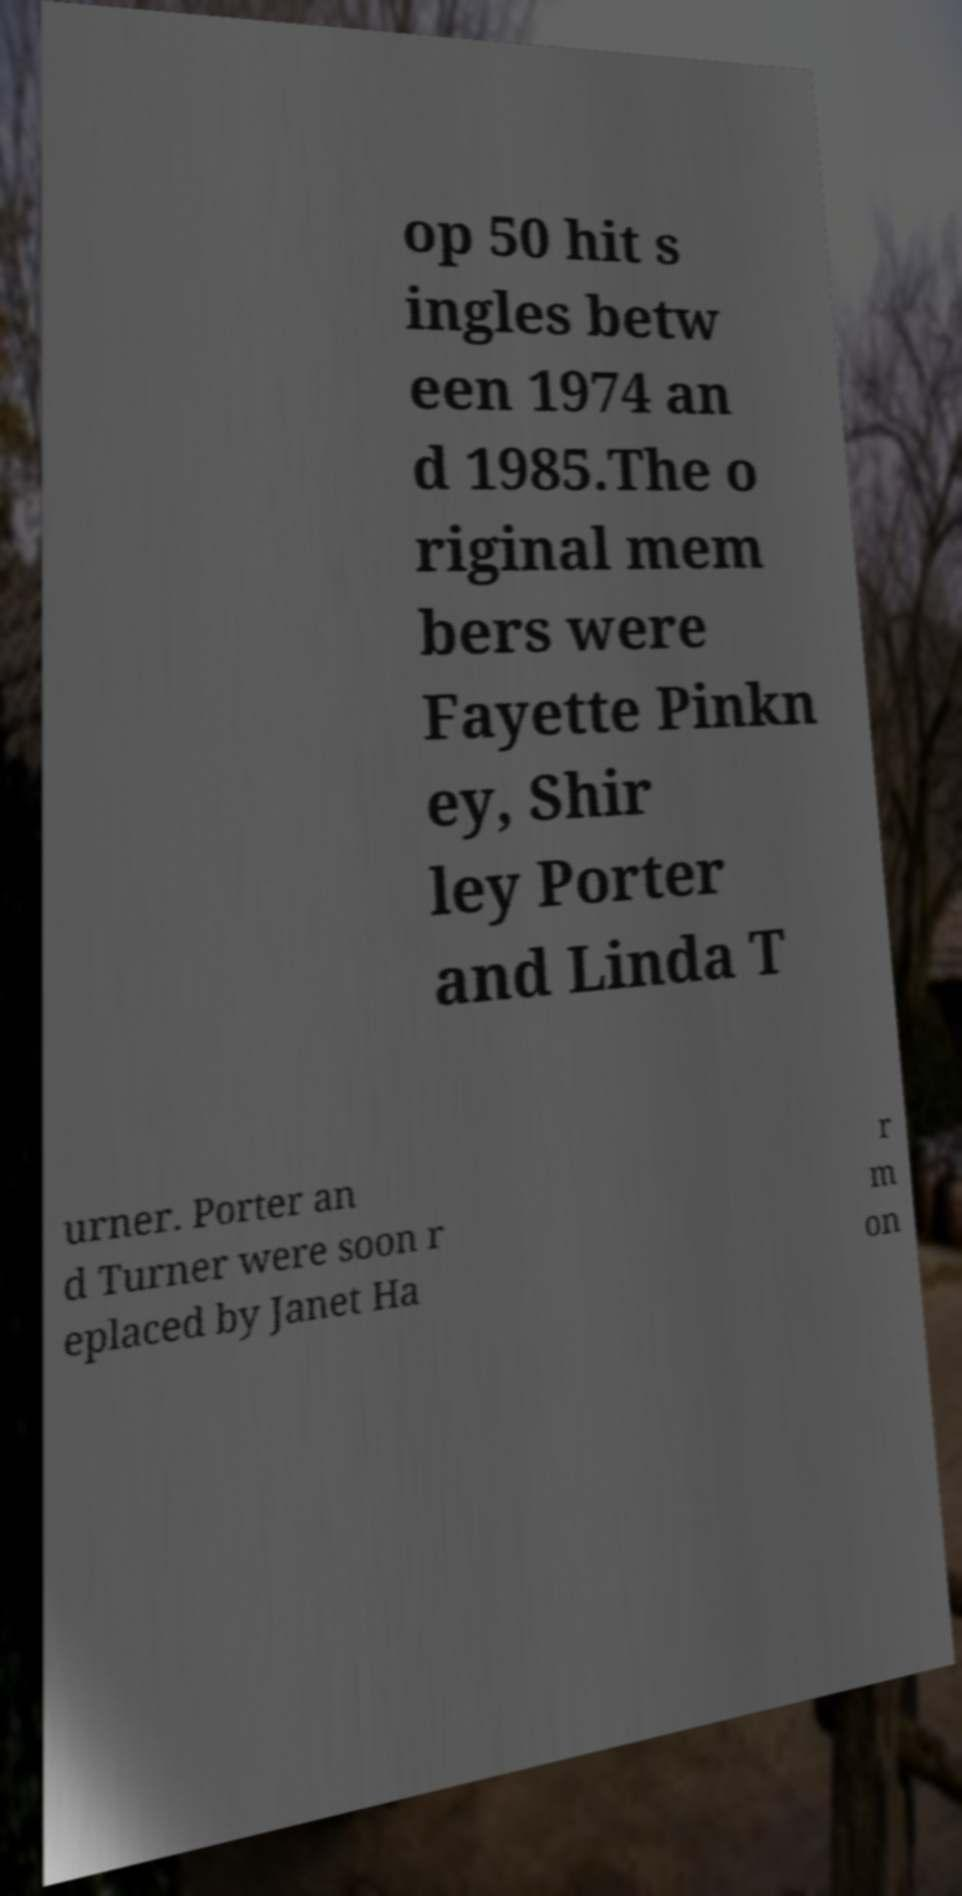Please read and relay the text visible in this image. What does it say? op 50 hit s ingles betw een 1974 an d 1985.The o riginal mem bers were Fayette Pinkn ey, Shir ley Porter and Linda T urner. Porter an d Turner were soon r eplaced by Janet Ha r m on 